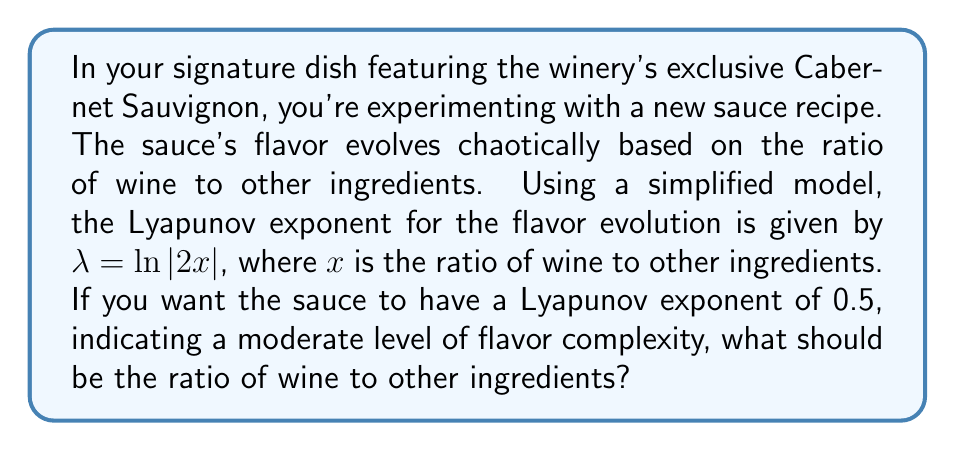Can you answer this question? To solve this problem, we'll follow these steps:

1) We're given that the Lyapunov exponent $\lambda = \ln|2x|$, where $x$ is the ratio of wine to other ingredients.

2) We want $\lambda = 0.5$. So we can set up the equation:

   $$0.5 = \ln|2x|$$

3) To solve for $x$, we need to apply the exponential function to both sides:

   $$e^{0.5} = e^{\ln|2x|}$$

4) The exponential and natural log cancel on the right side:

   $$e^{0.5} = |2x|$$

5) We can calculate $e^{0.5}$:

   $$e^{0.5} \approx 1.6487$$

6) So our equation is now:

   $$1.6487 = |2x|$$

7) Divide both sides by 2:

   $$0.82435 = |x|$$

8) Since $x$ represents a ratio, it should be positive, so we can remove the absolute value signs:

   $$x = 0.82435$$

Therefore, the ratio of wine to other ingredients should be approximately 0.82435 to 1.
Answer: 0.82435:1 